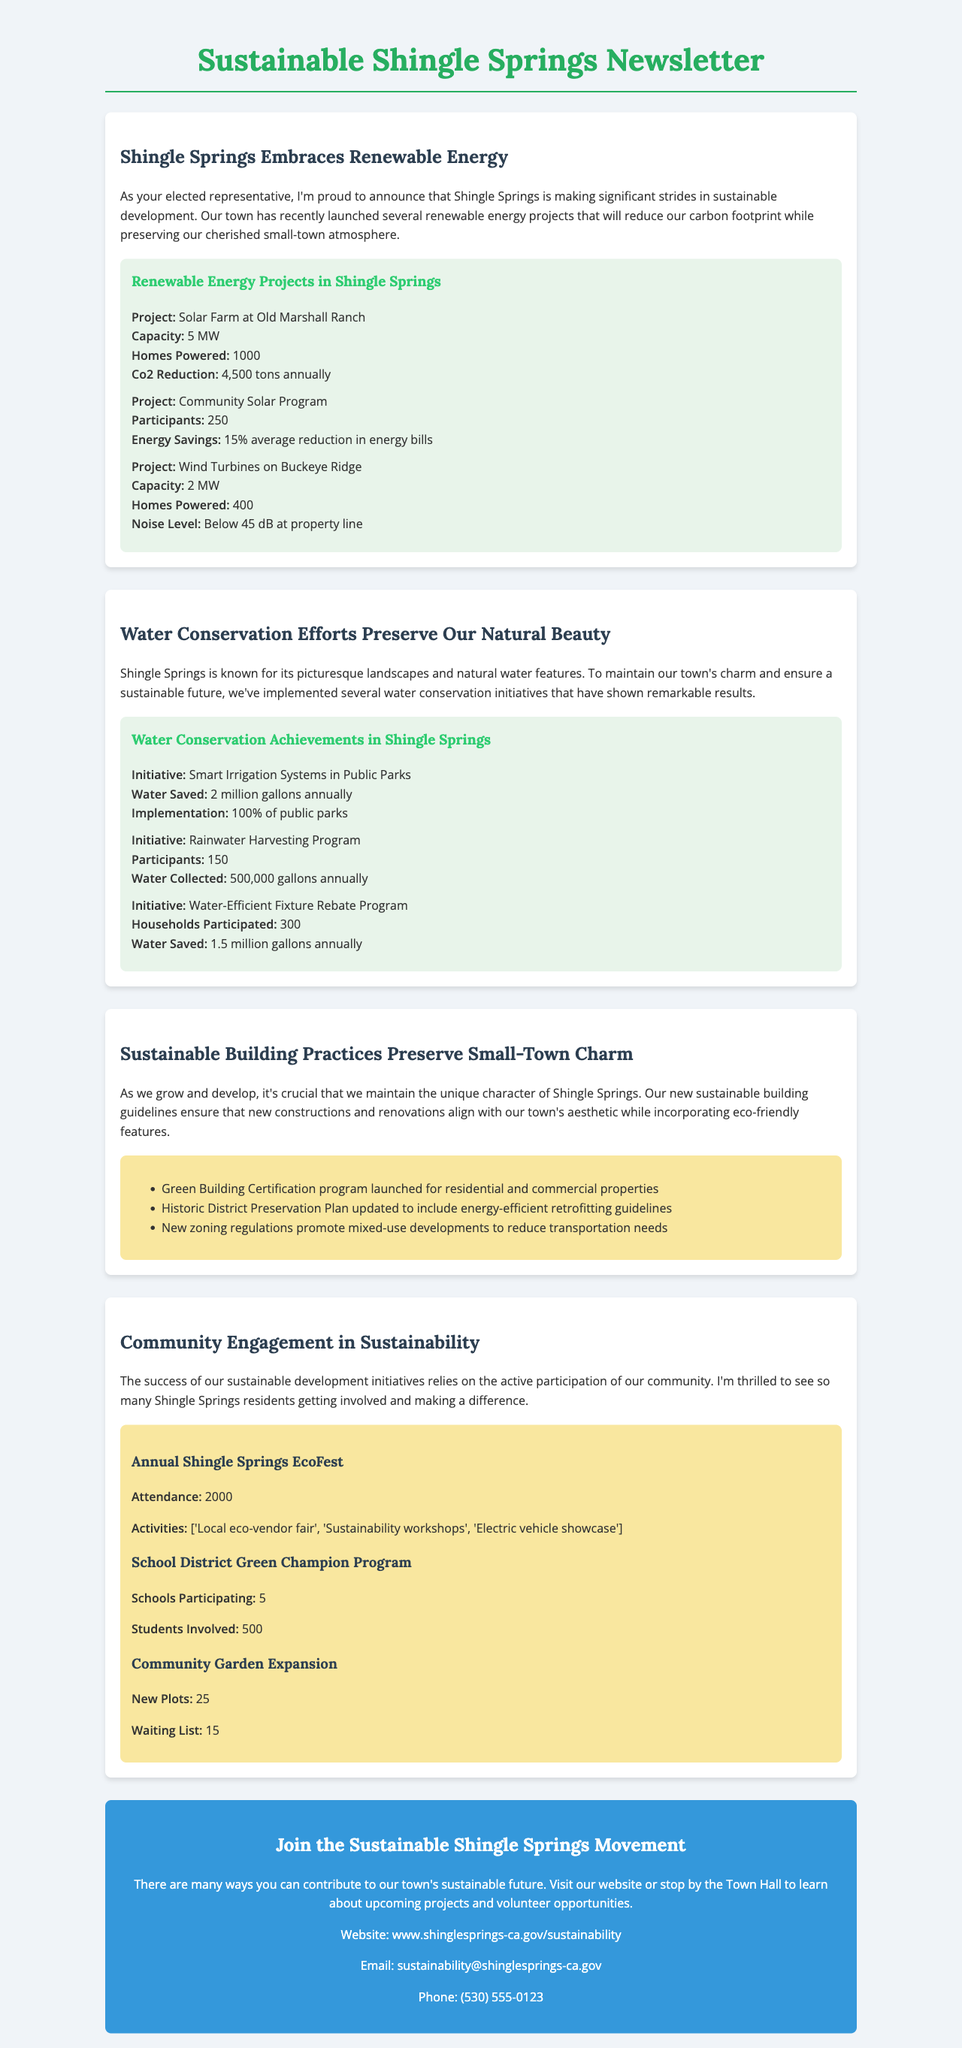What is the capacity of the Solar Farm at Old Marshall Ranch? The capacity refers to the amount of energy the solar farm can produce, which is 5 MW.
Answer: 5 MW How many tons of CO2 will be reduced annually by the Solar Farm at Old Marshall Ranch? The document states that the solar farm will reduce CO2 emissions by 4,500 tons annually.
Answer: 4,500 tons What initiative saves 2 million gallons of water annually? The Smart Irrigation Systems in Public Parks are designed to save water, totaling 2 million gallons saved each year.
Answer: Smart Irrigation Systems in Public Parks How many students are involved in the School District Green Champion Program? The number of students participating in the program is mentioned as 500.
Answer: 500 What is the average energy bill reduction for participants of the Community Solar Program? According to the document, participants experience a 15% average reduction in their energy bills.
Answer: 15% Which initiative has the highest number of participants? The initiative with the most participants, at 250, is the Community Solar Program.
Answer: Community Solar Program How many homes can the Wind Turbines on Buckeye Ridge power? The Wind Turbines can power 400 homes, as stated in the document.
Answer: 400 What does the call to action encourage residents to do? The call to action encourages residents to contribute to the town's sustainable future through participation in projects and volunteer opportunities.
Answer: Join the Sustainable Shingle Springs Movement How many new plots were added in the Community Garden Expansion? The document mentions that 25 new plots have been added to the Community Garden.
Answer: 25 